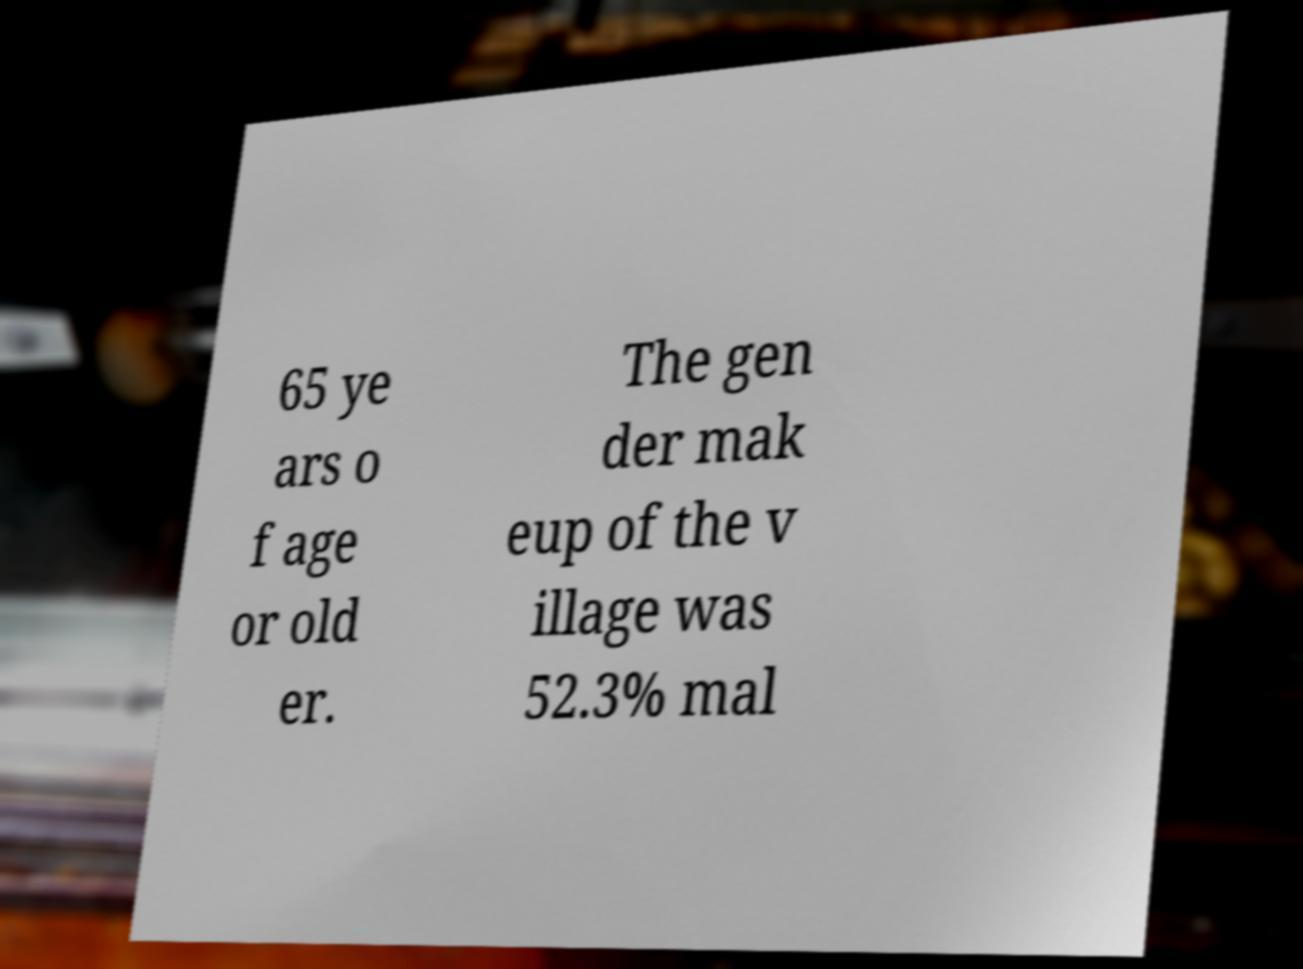Could you assist in decoding the text presented in this image and type it out clearly? 65 ye ars o f age or old er. The gen der mak eup of the v illage was 52.3% mal 